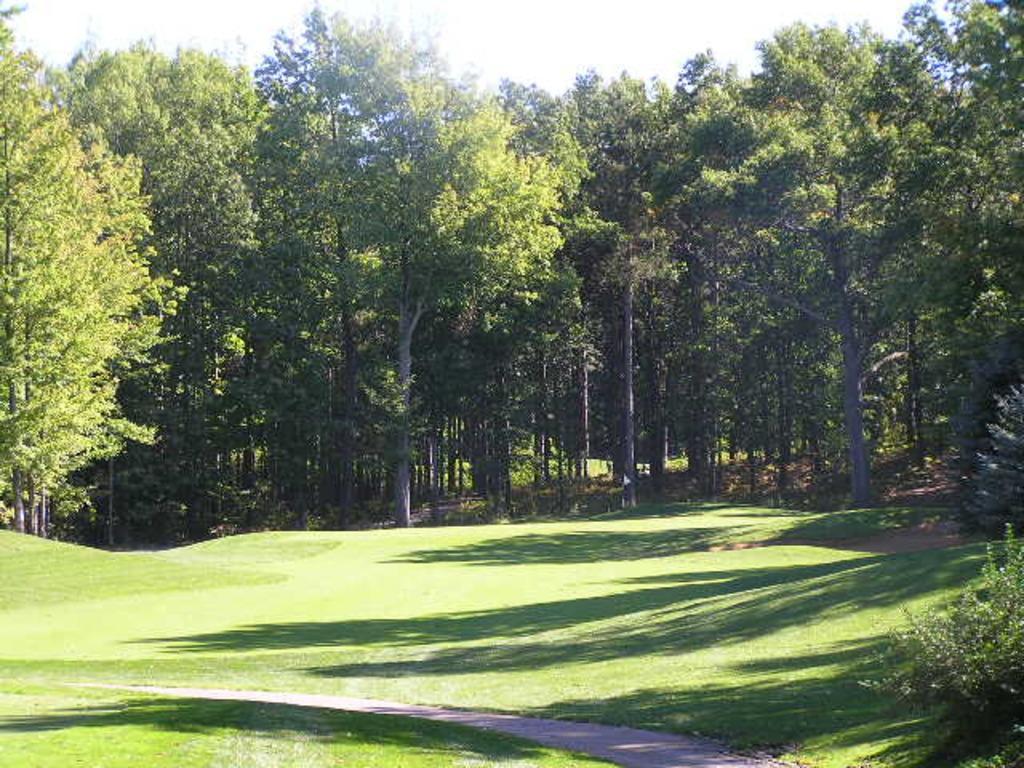Describe this image in one or two sentences. This picture shows trees and grass on the ground and we see a cloudy sky. 